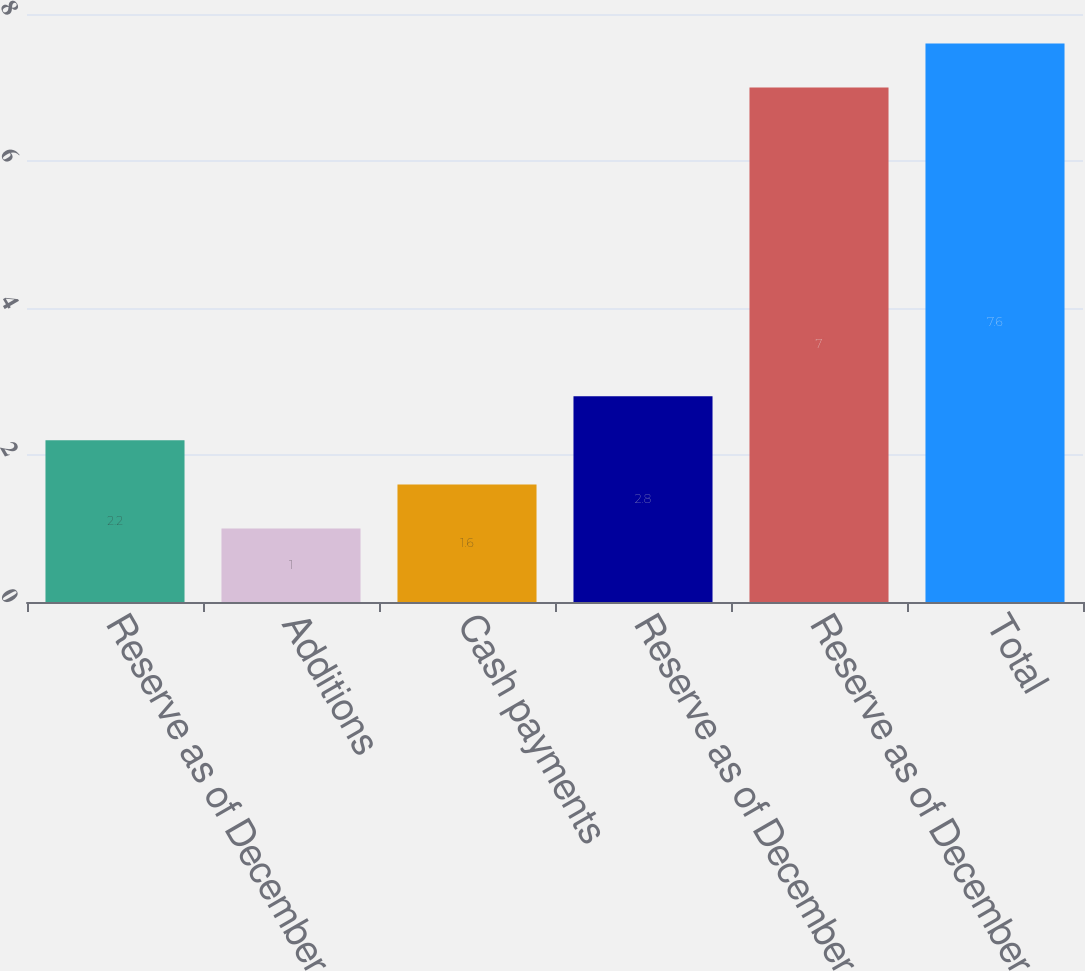Convert chart. <chart><loc_0><loc_0><loc_500><loc_500><bar_chart><fcel>Reserve as of December 31 2007<fcel>Additions<fcel>Cash payments<fcel>Reserve as of December 31 2008<fcel>Reserve as of December 31 2009<fcel>Total<nl><fcel>2.2<fcel>1<fcel>1.6<fcel>2.8<fcel>7<fcel>7.6<nl></chart> 